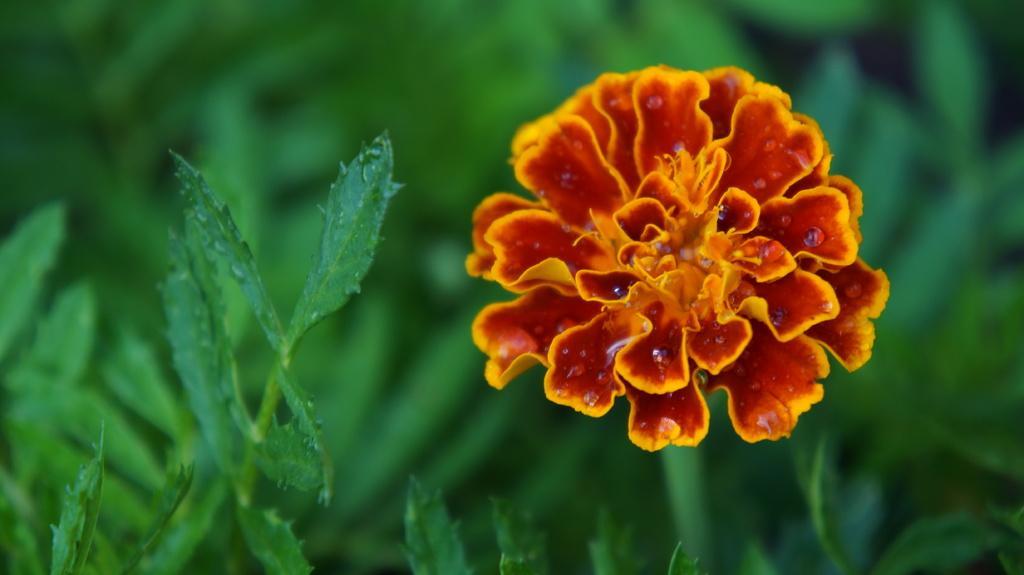Please provide a concise description of this image. In this image, there are a few plants. We can also see a flower and the background is blurred. 